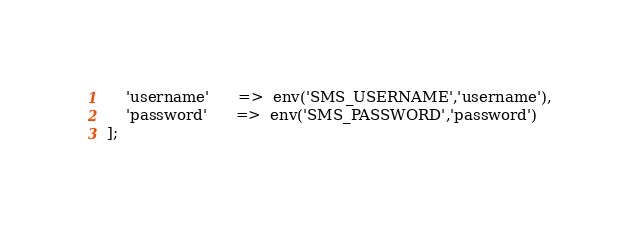<code> <loc_0><loc_0><loc_500><loc_500><_PHP_>    'username'      =>  env('SMS_USERNAME','username'),
    'password'      =>  env('SMS_PASSWORD','password')
];
</code> 